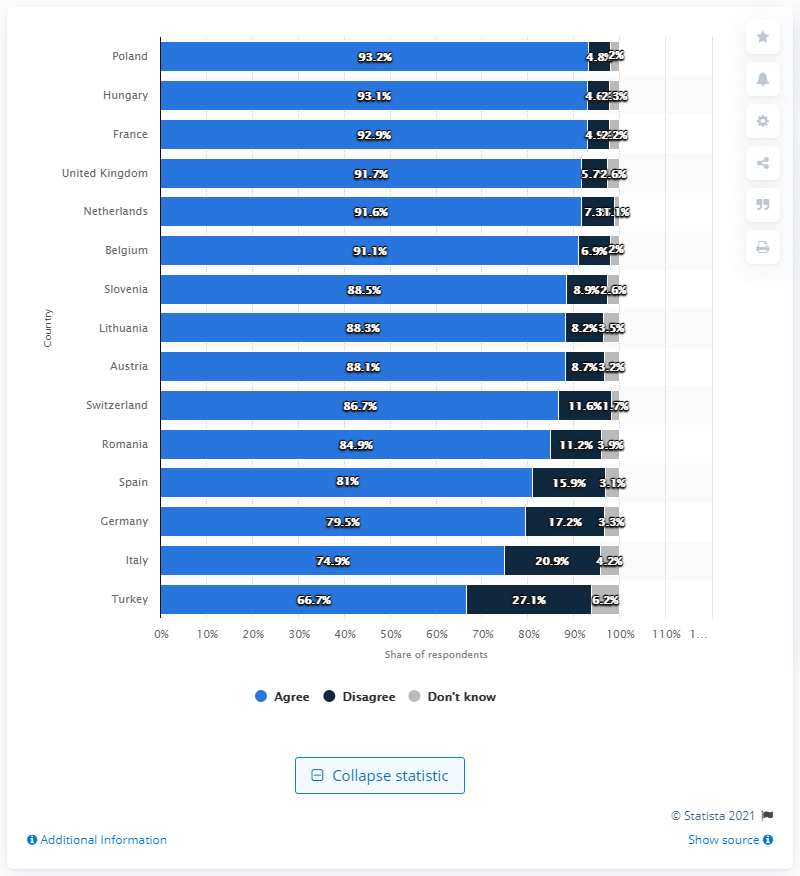Indicate a few pertinent items in this graphic. 79.5% of German teenage respondents believe that a woman can get pregnant the first time she has sex. 